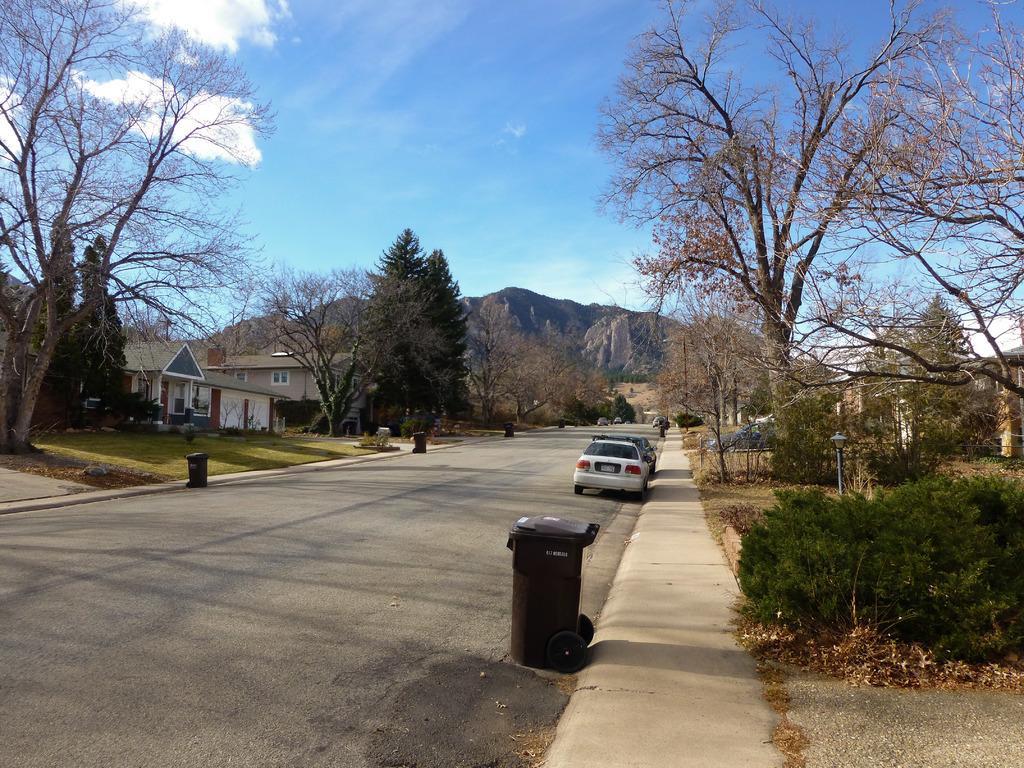How would you summarize this image in a sentence or two? On the left side there is a road. There are few cars on the road and also there is a dustbin. On the both sides of the road I can see the trees and buildings. On the right side there are few plants. In the background there is a rock mountain. At the top of the image I can see the sky and clouds. 